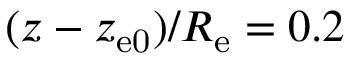Convert formula to latex. <formula><loc_0><loc_0><loc_500><loc_500>( z - z _ { e 0 } ) / R _ { e } = 0 . 2</formula> 